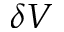<formula> <loc_0><loc_0><loc_500><loc_500>\delta V</formula> 